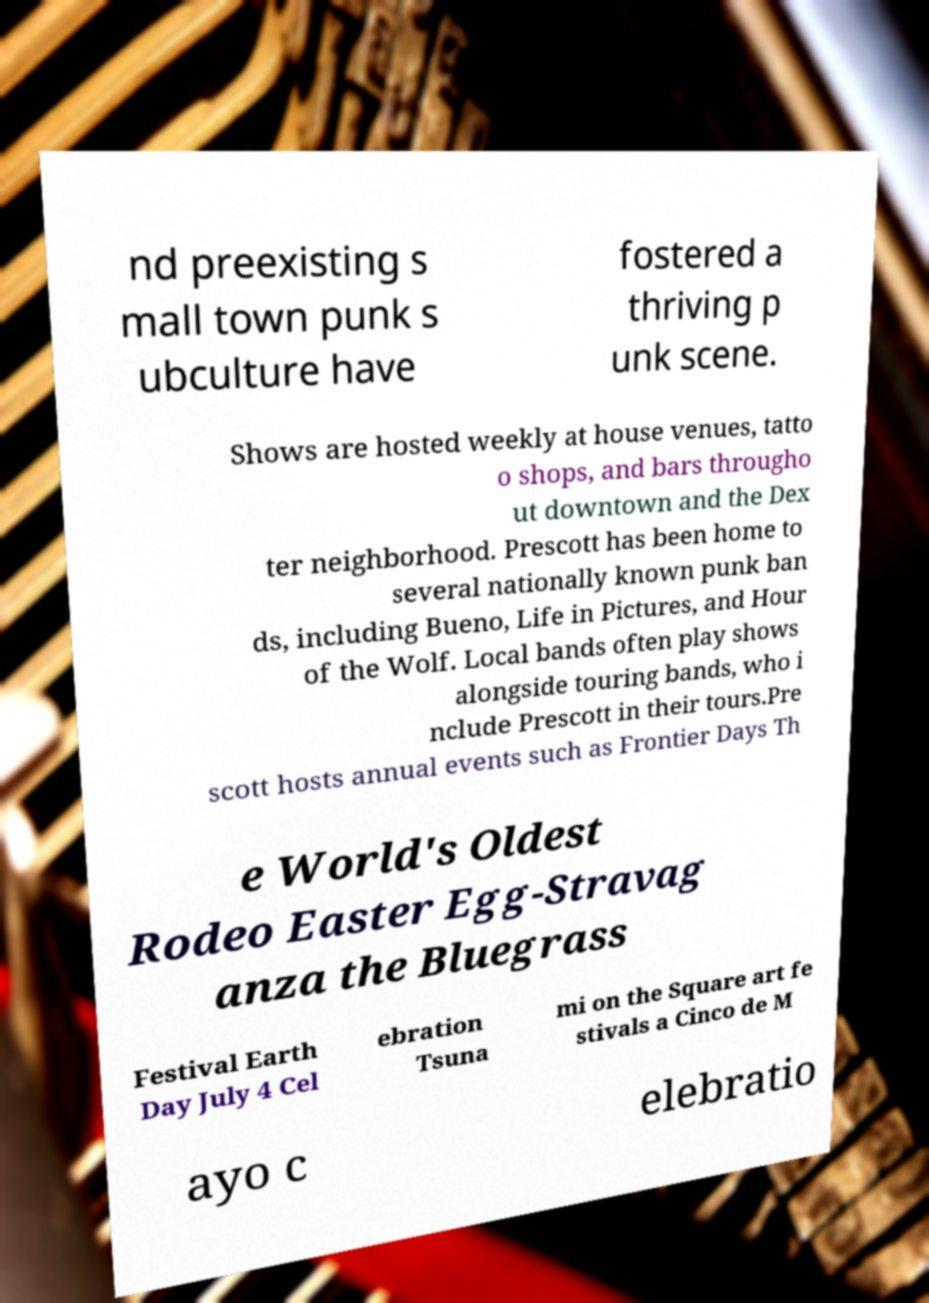There's text embedded in this image that I need extracted. Can you transcribe it verbatim? nd preexisting s mall town punk s ubculture have fostered a thriving p unk scene. Shows are hosted weekly at house venues, tatto o shops, and bars througho ut downtown and the Dex ter neighborhood. Prescott has been home to several nationally known punk ban ds, including Bueno, Life in Pictures, and Hour of the Wolf. Local bands often play shows alongside touring bands, who i nclude Prescott in their tours.Pre scott hosts annual events such as Frontier Days Th e World's Oldest Rodeo Easter Egg-Stravag anza the Bluegrass Festival Earth Day July 4 Cel ebration Tsuna mi on the Square art fe stivals a Cinco de M ayo c elebratio 